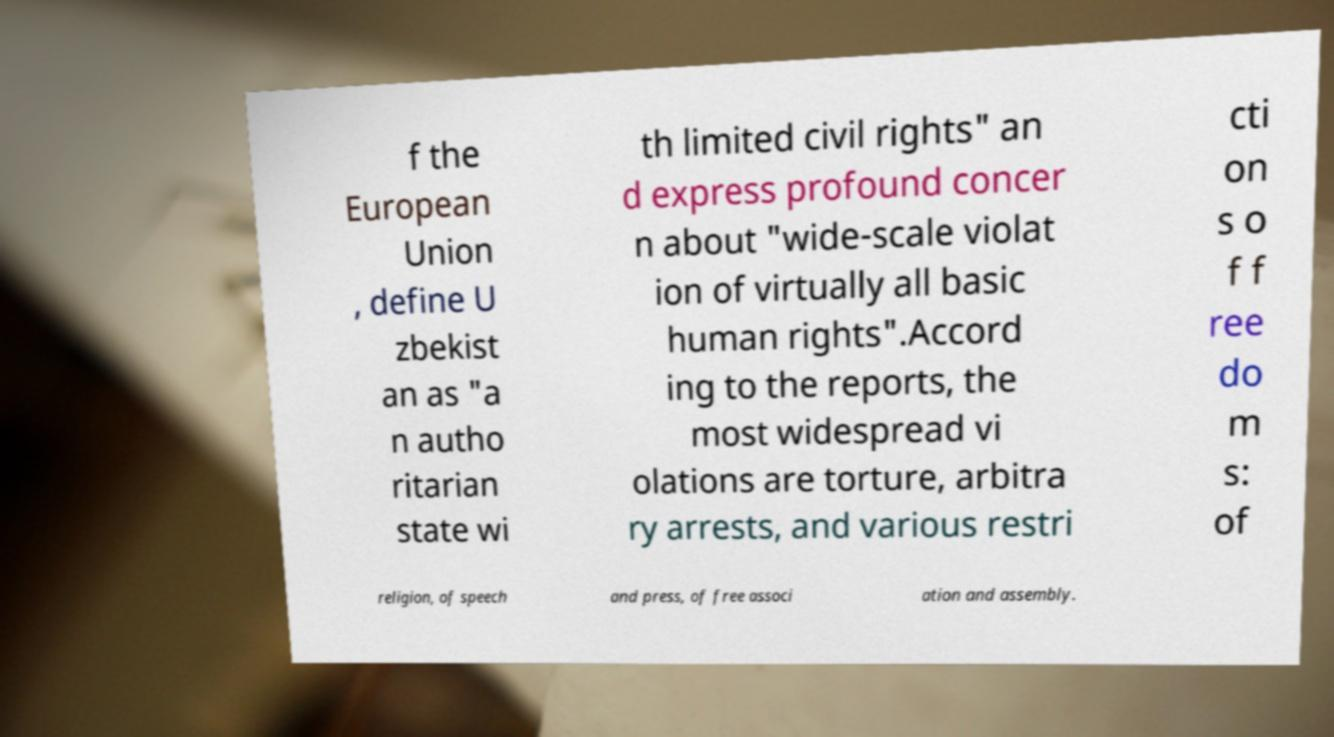Please identify and transcribe the text found in this image. f the European Union , define U zbekist an as "a n autho ritarian state wi th limited civil rights" an d express profound concer n about "wide-scale violat ion of virtually all basic human rights".Accord ing to the reports, the most widespread vi olations are torture, arbitra ry arrests, and various restri cti on s o f f ree do m s: of religion, of speech and press, of free associ ation and assembly. 